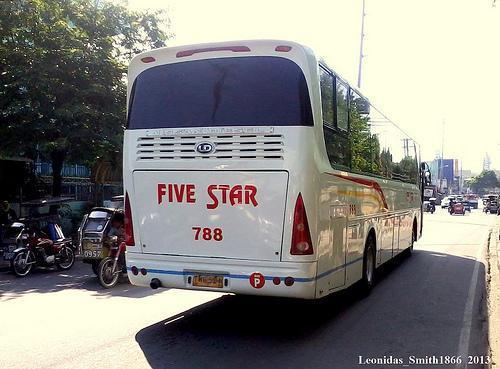How many buses on the street?
Give a very brief answer. 1. 